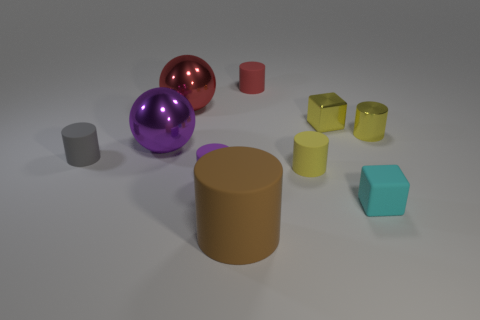Subtract all yellow cylinders. How many cylinders are left? 4 Subtract all red cylinders. How many cylinders are left? 5 Subtract 5 cylinders. How many cylinders are left? 1 Subtract all cylinders. How many objects are left? 4 Subtract all purple metal spheres. Subtract all large brown cylinders. How many objects are left? 8 Add 4 shiny balls. How many shiny balls are left? 6 Add 6 tiny yellow matte objects. How many tiny yellow matte objects exist? 7 Subtract 0 purple blocks. How many objects are left? 10 Subtract all gray cylinders. Subtract all green cubes. How many cylinders are left? 5 Subtract all purple balls. How many red blocks are left? 0 